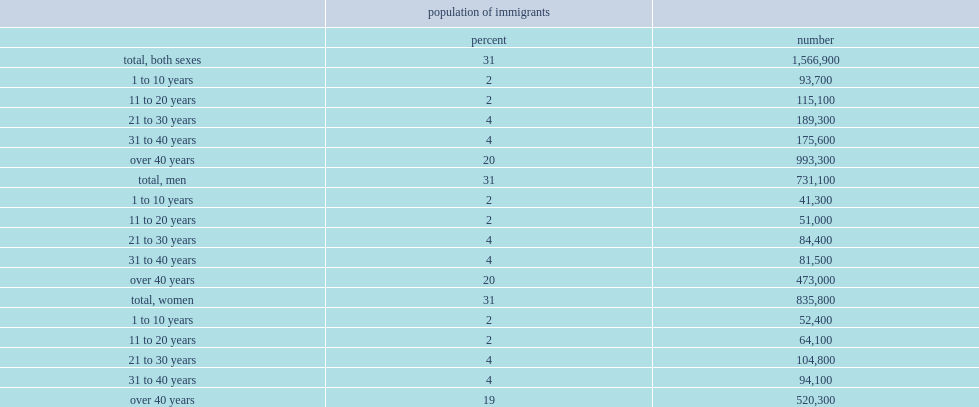Overall, what is the percentage of this population were immigrants in 2016? 31.0. Overall, what is the percentage of whom were senior immigrants who landed over 40 years ago in 2016? 20.0. What is the percentage of immigrants who landed between 21 and 40 years before the census statisticted in 2016? 8. What is the percentage of immigrants who landed between 11 to 20 years before the census statisticted in 2016? 2.0. What is the percentage of immigrants who landed previous decade before the census statisticted in 2016? 2.0. In 2016, how many senior immigrants had landed 1 to 10 years before the census? 93700.0. In 2016, how many senior immigrants had landed 11 to 20 years before the census? 115100.0. Would you be able to parse every entry in this table? {'header': ['', 'population of immigrants', ''], 'rows': [['', 'percent', 'number'], ['total, both sexes', '31', '1,566,900'], ['1 to 10 years', '2', '93,700'], ['11 to 20 years', '2', '115,100'], ['21 to 30 years', '4', '189,300'], ['31 to 40 years', '4', '175,600'], ['over 40 years', '20', '993,300'], ['total, men', '31', '731,100'], ['1 to 10 years', '2', '41,300'], ['11 to 20 years', '2', '51,000'], ['21 to 30 years', '4', '84,400'], ['31 to 40 years', '4', '81,500'], ['over 40 years', '20', '473,000'], ['total, women', '31', '835,800'], ['1 to 10 years', '2', '52,400'], ['11 to 20 years', '2', '64,100'], ['21 to 30 years', '4', '104,800'], ['31 to 40 years', '4', '94,100'], ['over 40 years', '19', '520,300']]} 